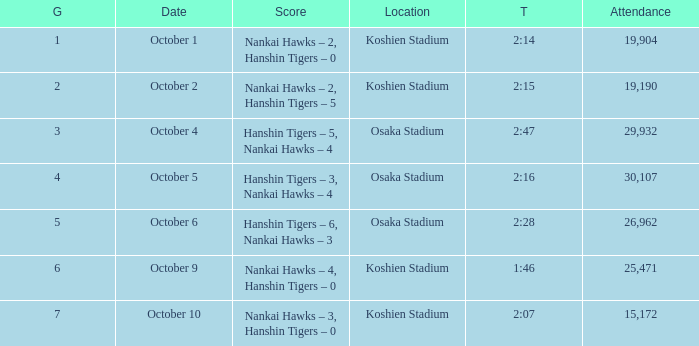How many games had a length of 2:14? 1.0. 